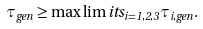<formula> <loc_0><loc_0><loc_500><loc_500>\tau _ { g e n } \geq \max \lim i t s _ { i = 1 , 2 , 3 } \tau _ { i , g e n } .</formula> 